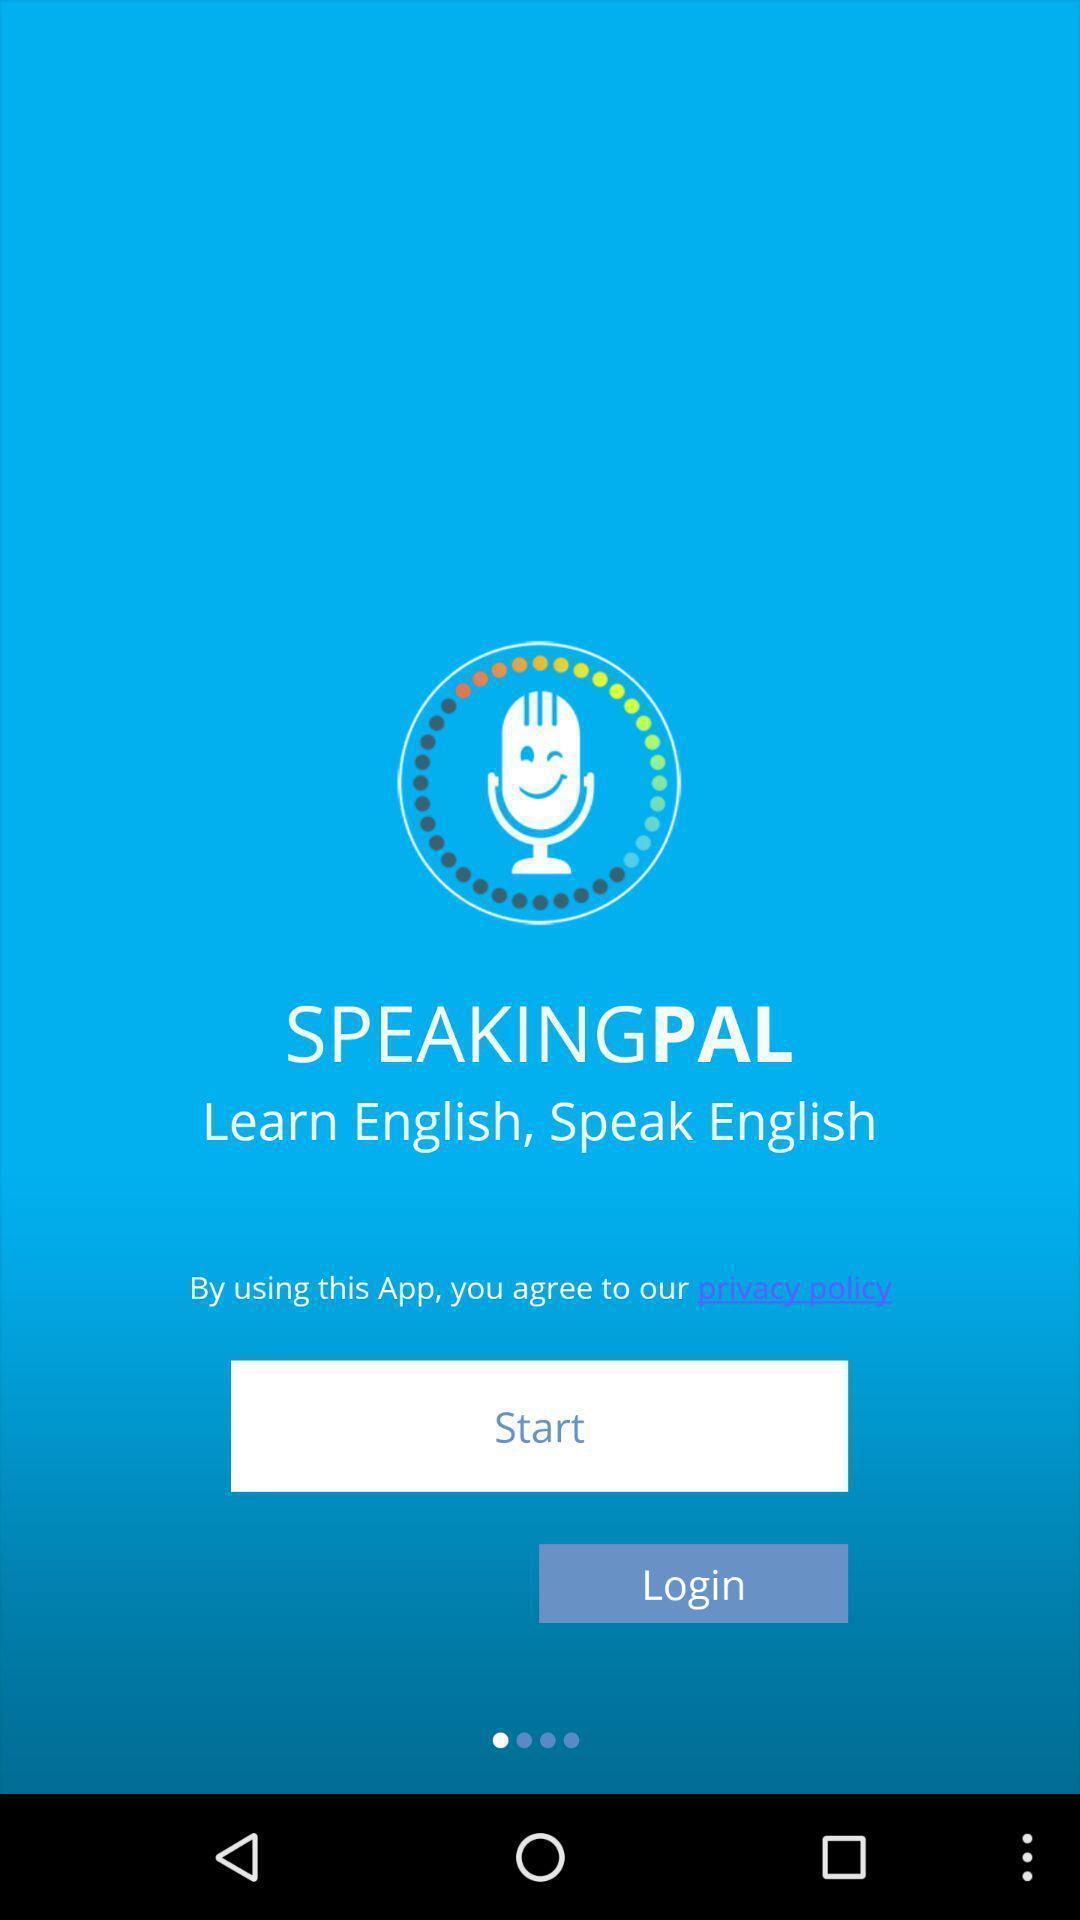Summarize the main components in this picture. Page showing about start and login option. 